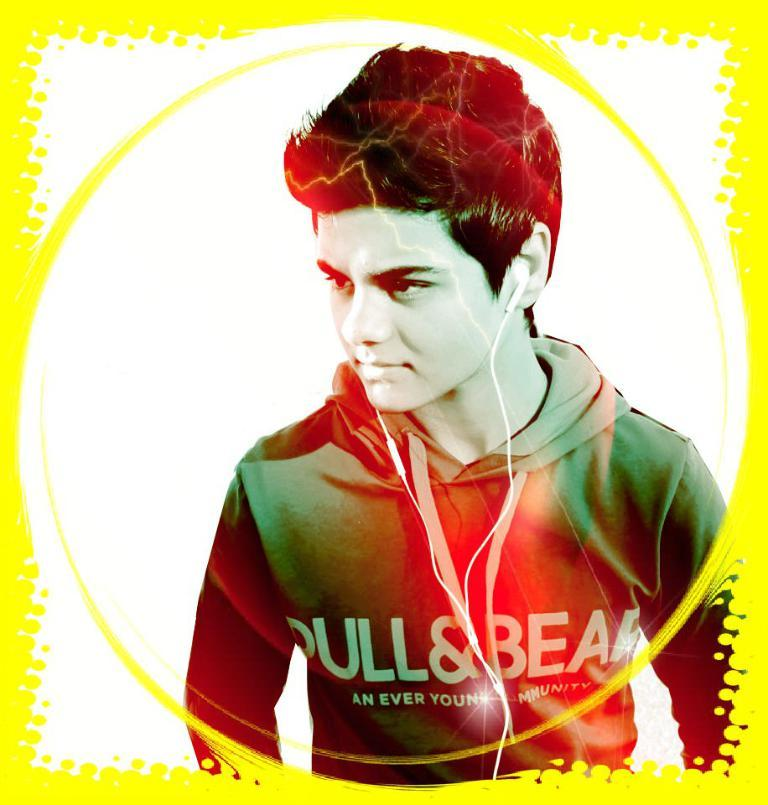<image>
Relay a brief, clear account of the picture shown. a boy that has a sweatshirt on that says an ever 